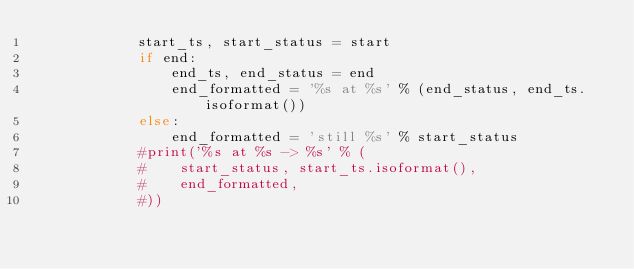Convert code to text. <code><loc_0><loc_0><loc_500><loc_500><_Python_>            start_ts, start_status = start
            if end:
                end_ts, end_status = end
                end_formatted = '%s at %s' % (end_status, end_ts.isoformat())
            else:
                end_formatted = 'still %s' % start_status
            #print('%s at %s -> %s' % (
            #    start_status, start_ts.isoformat(),
            #    end_formatted,
            #))</code> 